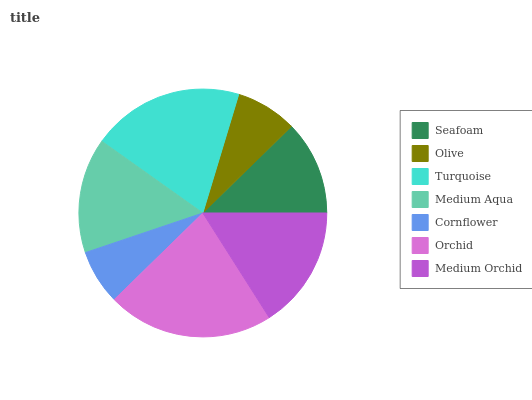Is Cornflower the minimum?
Answer yes or no. Yes. Is Orchid the maximum?
Answer yes or no. Yes. Is Olive the minimum?
Answer yes or no. No. Is Olive the maximum?
Answer yes or no. No. Is Seafoam greater than Olive?
Answer yes or no. Yes. Is Olive less than Seafoam?
Answer yes or no. Yes. Is Olive greater than Seafoam?
Answer yes or no. No. Is Seafoam less than Olive?
Answer yes or no. No. Is Medium Aqua the high median?
Answer yes or no. Yes. Is Medium Aqua the low median?
Answer yes or no. Yes. Is Medium Orchid the high median?
Answer yes or no. No. Is Cornflower the low median?
Answer yes or no. No. 